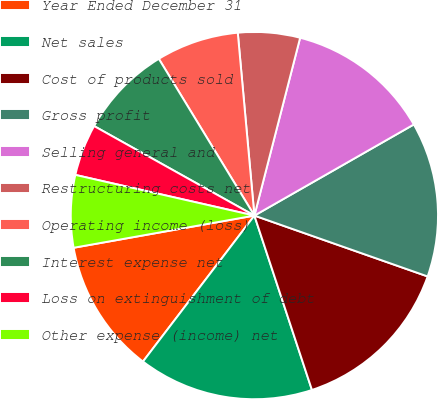Convert chart to OTSL. <chart><loc_0><loc_0><loc_500><loc_500><pie_chart><fcel>Year Ended December 31<fcel>Net sales<fcel>Cost of products sold<fcel>Gross profit<fcel>Selling general and<fcel>Restructuring costs net<fcel>Operating income (loss)<fcel>Interest expense net<fcel>Loss on extinguishment of debt<fcel>Other expense (income) net<nl><fcel>11.82%<fcel>15.45%<fcel>14.55%<fcel>13.64%<fcel>12.73%<fcel>5.45%<fcel>7.27%<fcel>8.18%<fcel>4.55%<fcel>6.36%<nl></chart> 